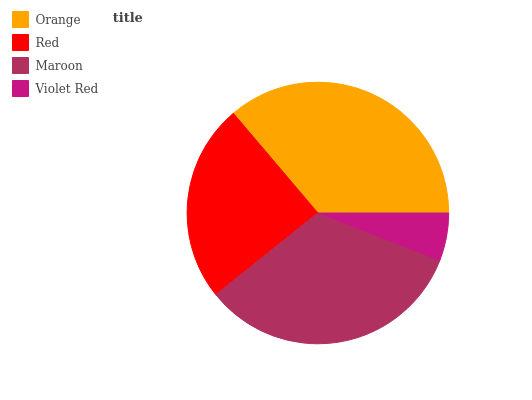Is Violet Red the minimum?
Answer yes or no. Yes. Is Orange the maximum?
Answer yes or no. Yes. Is Red the minimum?
Answer yes or no. No. Is Red the maximum?
Answer yes or no. No. Is Orange greater than Red?
Answer yes or no. Yes. Is Red less than Orange?
Answer yes or no. Yes. Is Red greater than Orange?
Answer yes or no. No. Is Orange less than Red?
Answer yes or no. No. Is Maroon the high median?
Answer yes or no. Yes. Is Red the low median?
Answer yes or no. Yes. Is Orange the high median?
Answer yes or no. No. Is Orange the low median?
Answer yes or no. No. 